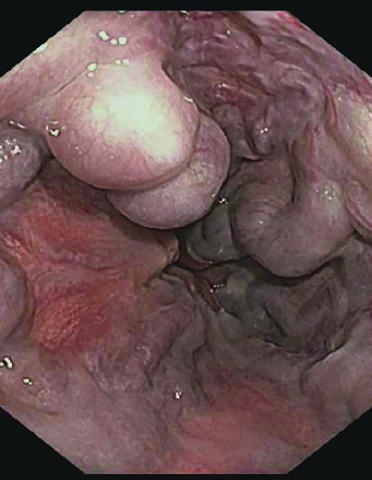what is more commonly used to identify varices?
Answer the question using a single word or phrase. Endoscopy 